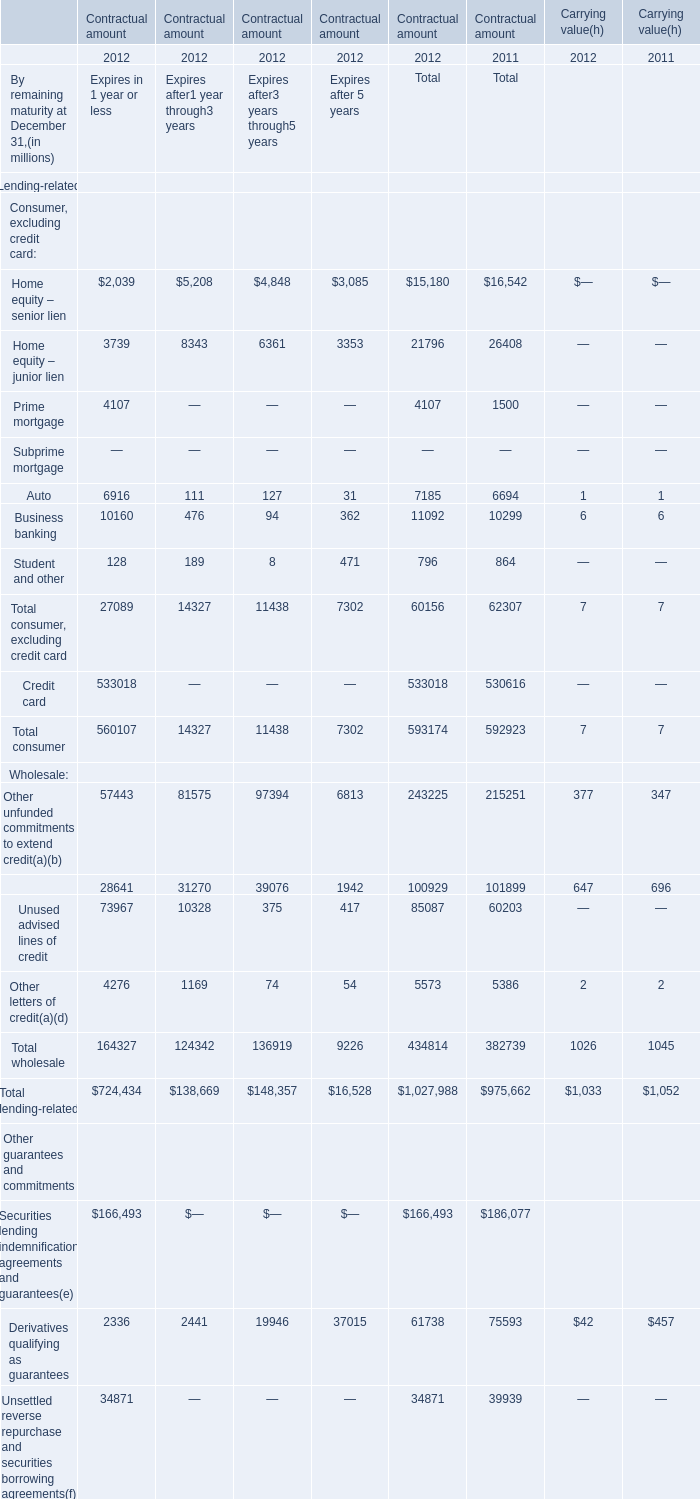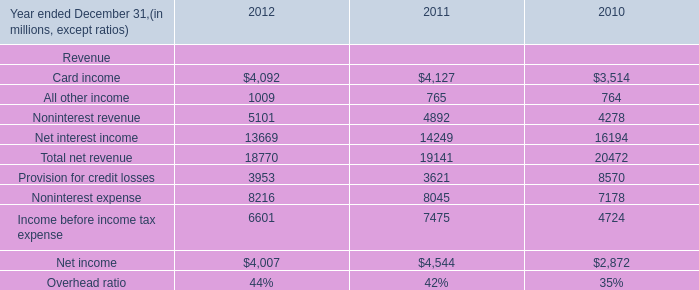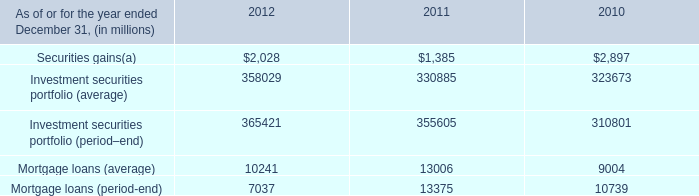What's the increasing rate of Home equity – senior lien in 2012? 
Computations: ((15180 - 16542) / 16542)
Answer: -0.08234. 